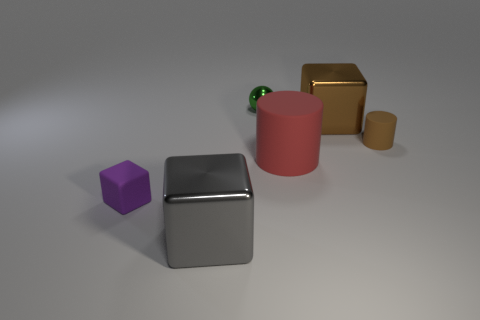Subtract all tiny purple rubber blocks. How many blocks are left? 2 Add 2 small purple things. How many objects exist? 8 Subtract all red cylinders. How many cylinders are left? 1 Subtract all spheres. How many objects are left? 5 Subtract 0 cyan balls. How many objects are left? 6 Subtract 2 cylinders. How many cylinders are left? 0 Subtract all brown cylinders. Subtract all brown spheres. How many cylinders are left? 1 Subtract all yellow cylinders. How many brown blocks are left? 1 Subtract all tiny brown matte objects. Subtract all big rubber cylinders. How many objects are left? 4 Add 6 brown matte objects. How many brown matte objects are left? 7 